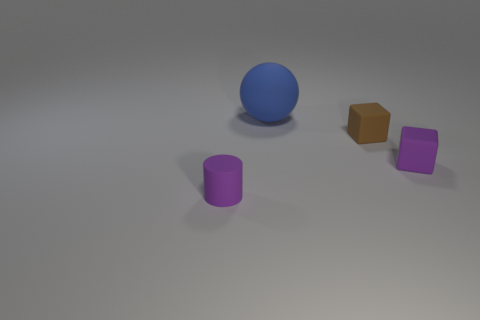What number of other objects are the same color as the tiny matte cylinder?
Your answer should be very brief. 1. Do the small purple matte thing right of the tiny brown cube and the small brown object have the same shape?
Give a very brief answer. Yes. Are there any other things that are the same color as the cylinder?
Offer a very short reply. Yes. The thing that is the same color as the tiny rubber cylinder is what shape?
Keep it short and to the point. Cube. There is a block that is in front of the small brown rubber block; is its color the same as the rubber cylinder?
Offer a terse response. Yes. There is a block that is the same size as the brown object; what color is it?
Your answer should be very brief. Purple. There is a object that is in front of the small brown matte block and on the left side of the brown rubber cube; what material is it?
Keep it short and to the point. Rubber. There is a thing that is on the left side of the matte sphere; is it the same size as the big matte thing?
Offer a very short reply. No. The tiny brown rubber object is what shape?
Provide a short and direct response. Cube. How many small purple rubber things have the same shape as the big matte object?
Make the answer very short. 0. 